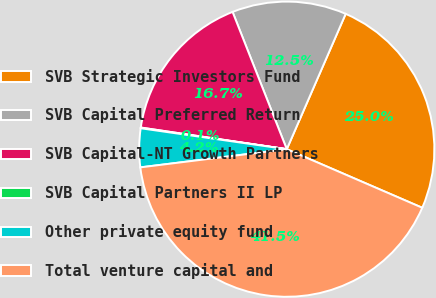Convert chart. <chart><loc_0><loc_0><loc_500><loc_500><pie_chart><fcel>SVB Strategic Investors Fund<fcel>SVB Capital Preferred Return<fcel>SVB Capital-NT Growth Partners<fcel>SVB Capital Partners II LP<fcel>Other private equity fund<fcel>Total venture capital and<nl><fcel>24.96%<fcel>12.52%<fcel>16.67%<fcel>0.08%<fcel>4.23%<fcel>41.54%<nl></chart> 